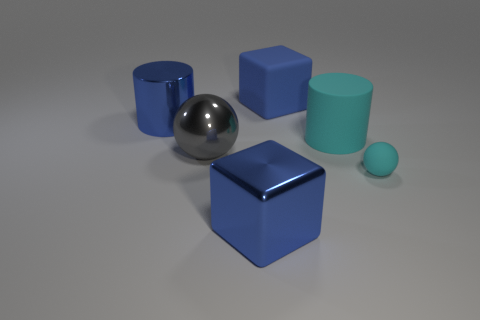What number of other things are the same size as the blue cylinder?
Provide a short and direct response. 4. There is a large cylinder behind the big cyan rubber thing; is its color the same as the large shiny cube?
Provide a succinct answer. Yes. There is a object that is both in front of the big metallic sphere and on the left side of the small cyan rubber sphere; what size is it?
Provide a short and direct response. Large. What number of big things are green matte cylinders or blue matte blocks?
Keep it short and to the point. 1. There is a large blue metal thing in front of the big cyan cylinder; what is its shape?
Ensure brevity in your answer.  Cube. How many cylinders are there?
Keep it short and to the point. 2. Is the material of the big sphere the same as the tiny object?
Provide a succinct answer. No. Is the number of big gray metal balls right of the small rubber object greater than the number of large blue metallic things?
Make the answer very short. No. What number of things are small balls or cylinders that are behind the big gray thing?
Give a very brief answer. 3. Are there more tiny balls to the left of the tiny rubber object than gray balls that are in front of the gray metallic object?
Give a very brief answer. No. 